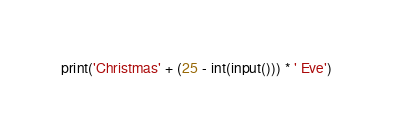<code> <loc_0><loc_0><loc_500><loc_500><_Python_>print('Christmas' + (25 - int(input())) * ' Eve')</code> 